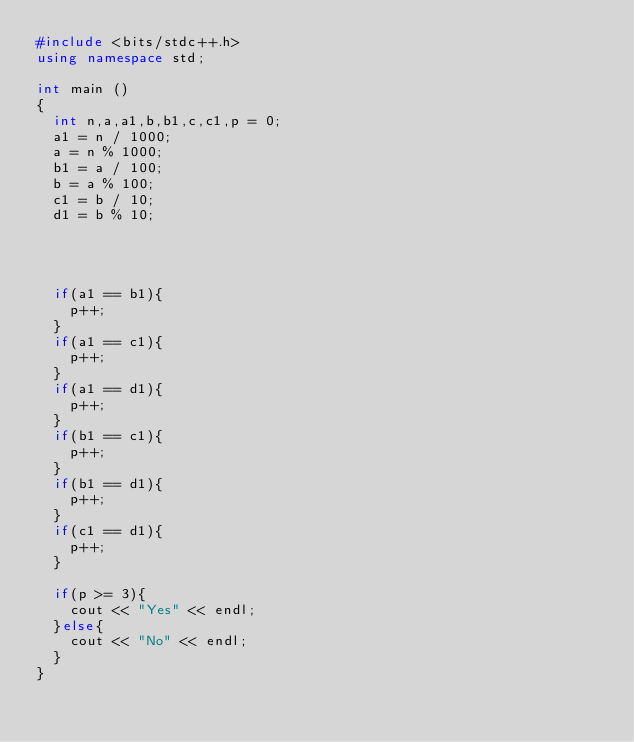Convert code to text. <code><loc_0><loc_0><loc_500><loc_500><_C++_>#include <bits/stdc++.h>
using namespace std;

int main ()
{
  int n,a,a1,b,b1,c,c1,p = 0;
  a1 = n / 1000;
  a = n % 1000;
  b1 = a / 100;
  b = a % 100;
  c1 = b / 10;
  d1 = b % 10;
  
  
 
  
  if(a1 == b1){
    p++;
  }
  if(a1 == c1){
    p++;
  }
  if(a1 == d1){
    p++;
  }
  if(b1 == c1){
    p++;
  }
  if(b1 == d1){
    p++;
  }
  if(c1 == d1){
    p++;
  }
  
  if(p >= 3){
	cout << "Yes" << endl;
  }else{
   	cout << "No" << endl;
  }
}</code> 